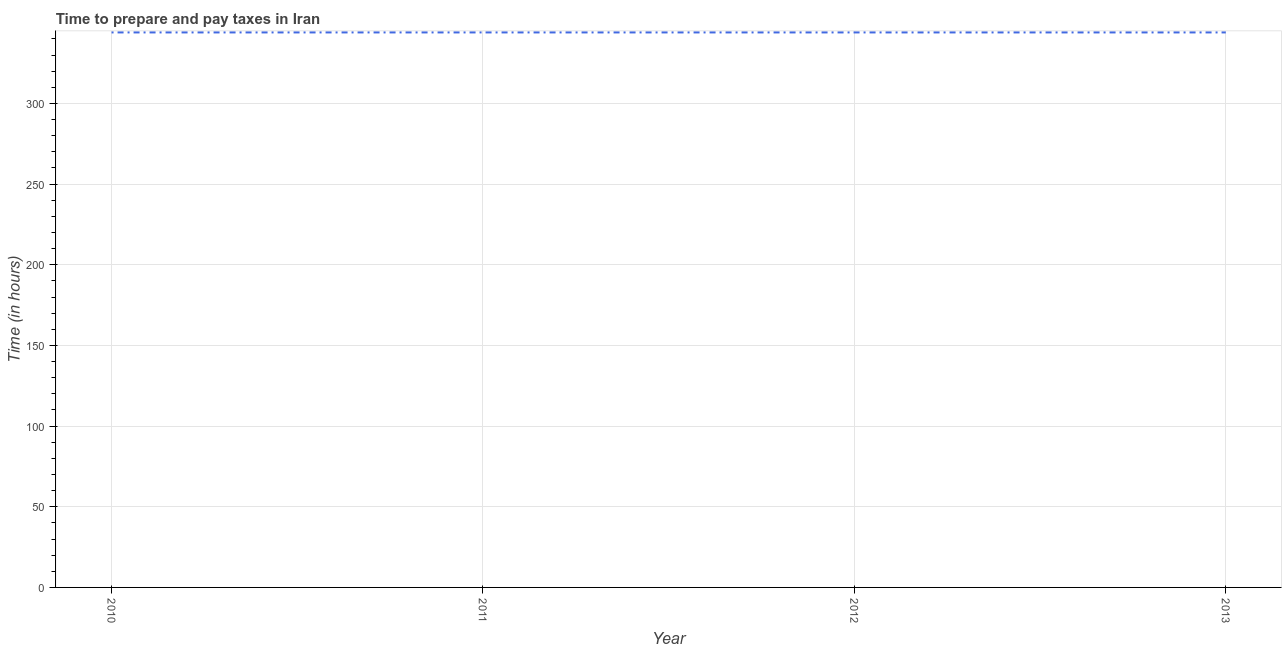What is the time to prepare and pay taxes in 2012?
Make the answer very short. 344. Across all years, what is the maximum time to prepare and pay taxes?
Make the answer very short. 344. Across all years, what is the minimum time to prepare and pay taxes?
Provide a succinct answer. 344. In which year was the time to prepare and pay taxes maximum?
Provide a succinct answer. 2010. In which year was the time to prepare and pay taxes minimum?
Keep it short and to the point. 2010. What is the sum of the time to prepare and pay taxes?
Provide a succinct answer. 1376. What is the average time to prepare and pay taxes per year?
Your response must be concise. 344. What is the median time to prepare and pay taxes?
Keep it short and to the point. 344. Is the time to prepare and pay taxes in 2012 less than that in 2013?
Give a very brief answer. No. What is the difference between the highest and the second highest time to prepare and pay taxes?
Your answer should be very brief. 0. In how many years, is the time to prepare and pay taxes greater than the average time to prepare and pay taxes taken over all years?
Ensure brevity in your answer.  0. How many years are there in the graph?
Your answer should be compact. 4. What is the difference between two consecutive major ticks on the Y-axis?
Provide a short and direct response. 50. Does the graph contain grids?
Keep it short and to the point. Yes. What is the title of the graph?
Make the answer very short. Time to prepare and pay taxes in Iran. What is the label or title of the Y-axis?
Make the answer very short. Time (in hours). What is the Time (in hours) in 2010?
Ensure brevity in your answer.  344. What is the Time (in hours) of 2011?
Ensure brevity in your answer.  344. What is the Time (in hours) of 2012?
Make the answer very short. 344. What is the Time (in hours) of 2013?
Your answer should be compact. 344. What is the difference between the Time (in hours) in 2011 and 2013?
Offer a terse response. 0. What is the difference between the Time (in hours) in 2012 and 2013?
Give a very brief answer. 0. What is the ratio of the Time (in hours) in 2010 to that in 2011?
Ensure brevity in your answer.  1. 